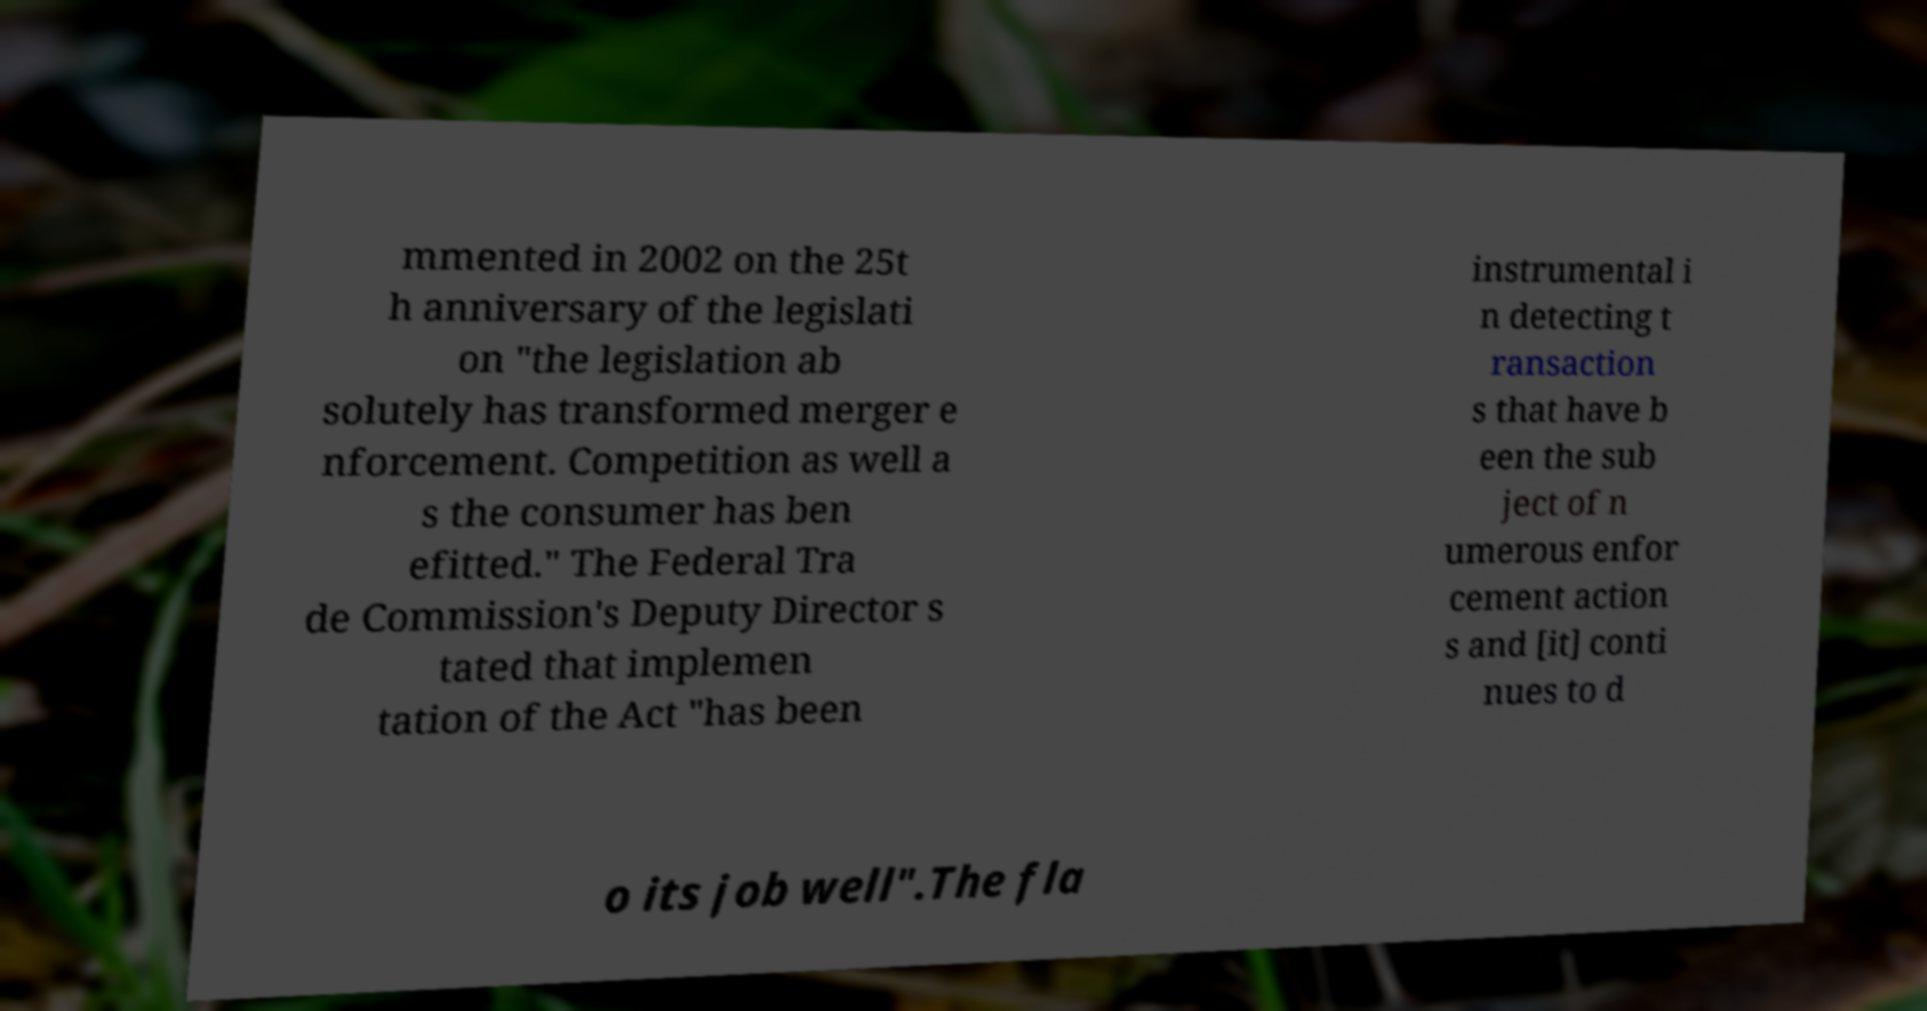I need the written content from this picture converted into text. Can you do that? mmented in 2002 on the 25t h anniversary of the legislati on "the legislation ab solutely has transformed merger e nforcement. Competition as well a s the consumer has ben efitted." The Federal Tra de Commission's Deputy Director s tated that implemen tation of the Act "has been instrumental i n detecting t ransaction s that have b een the sub ject of n umerous enfor cement action s and [it] conti nues to d o its job well".The fla 